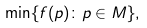<formula> <loc_0><loc_0><loc_500><loc_500>\min \{ f ( p ) \colon p \in M \} ,</formula> 